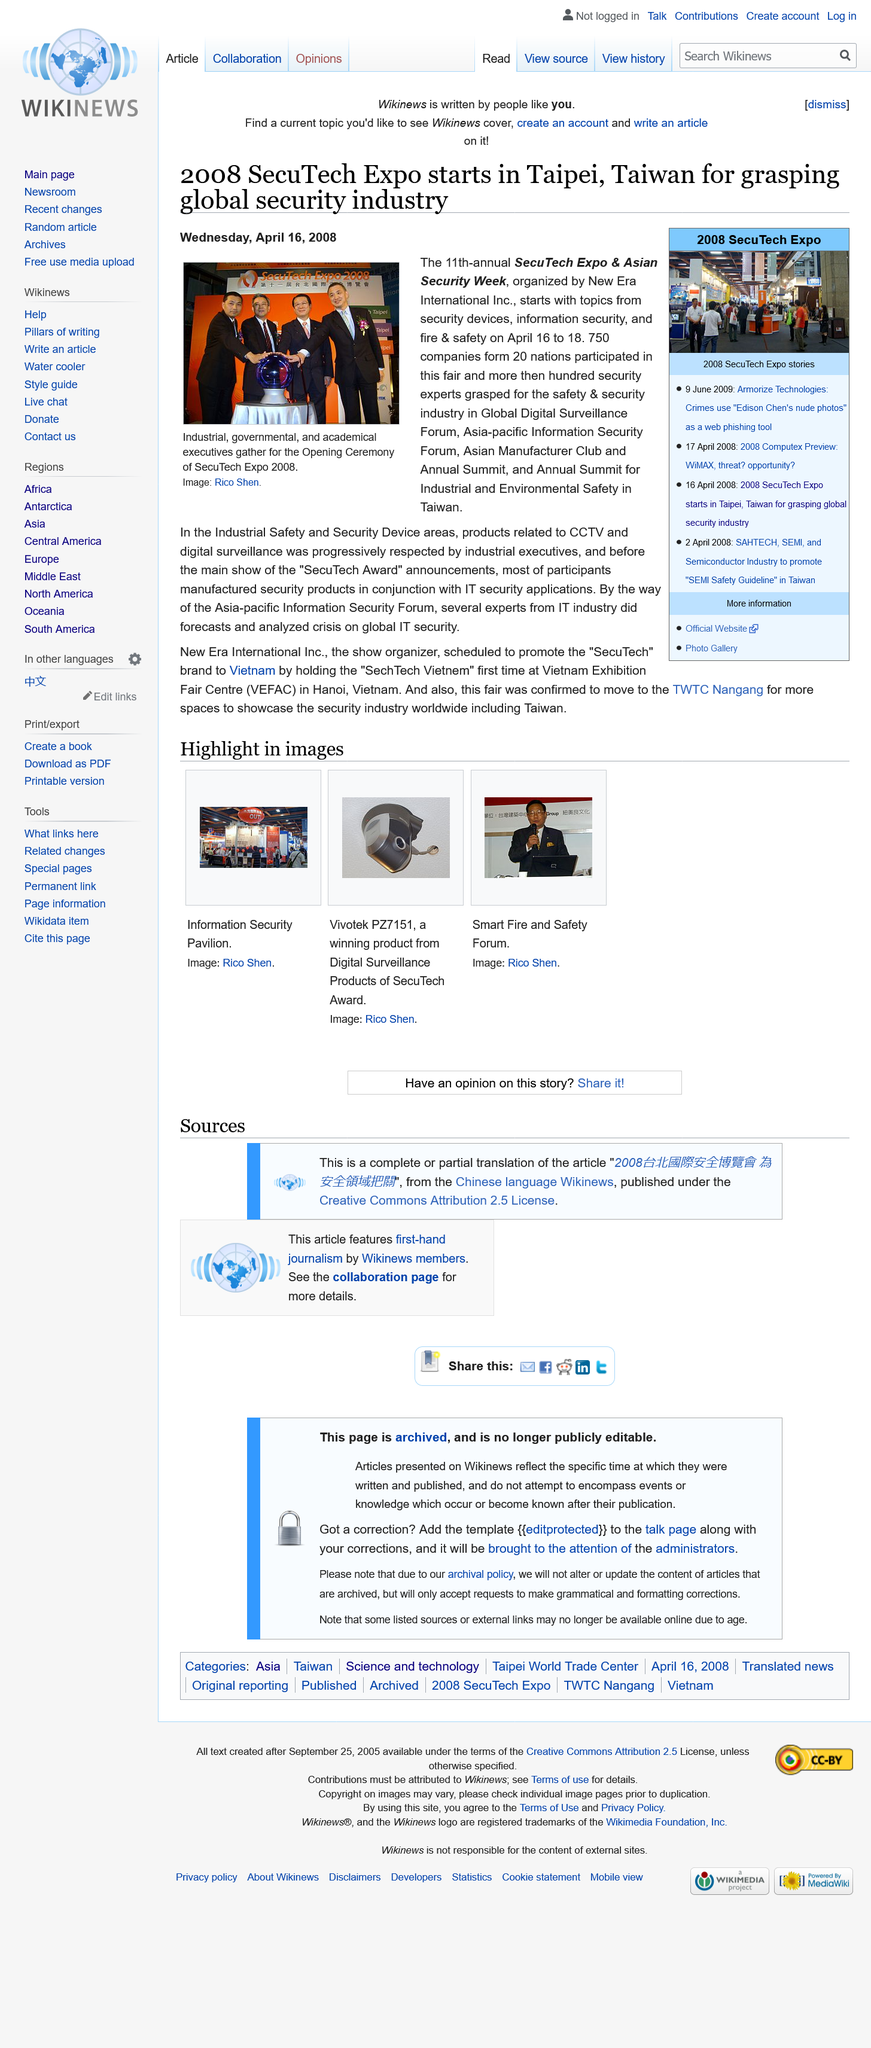Specify some key components in this picture. The individuals in the image are industrial, governmental, and academic executives. The 11th-annual SecuTech expo & Asian security week is organized by New Era International Inc. The image depicts four people. 